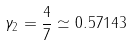<formula> <loc_0><loc_0><loc_500><loc_500>\gamma _ { 2 } = \frac { 4 } { 7 } \simeq 0 . 5 7 1 4 3</formula> 